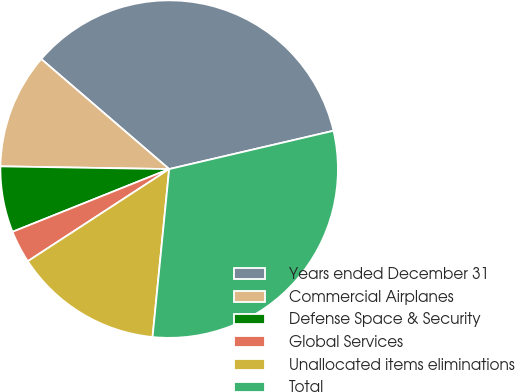<chart> <loc_0><loc_0><loc_500><loc_500><pie_chart><fcel>Years ended December 31<fcel>Commercial Airplanes<fcel>Defense Space & Security<fcel>Global Services<fcel>Unallocated items eliminations<fcel>Total<nl><fcel>35.05%<fcel>11.05%<fcel>6.32%<fcel>3.13%<fcel>14.24%<fcel>30.22%<nl></chart> 